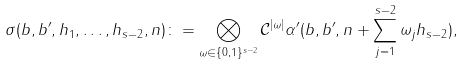<formula> <loc_0><loc_0><loc_500><loc_500>\sigma ( b , b ^ { \prime } , h _ { 1 } , \dots , h _ { s - 2 } , n ) \colon = \bigotimes _ { \omega \in \{ 0 , 1 \} ^ { s - 2 } } { \mathcal { C } } ^ { | \omega | } \alpha ^ { \prime } ( b , b ^ { \prime } , n + \sum _ { j = 1 } ^ { s - 2 } \omega _ { j } h _ { s - 2 } ) ,</formula> 